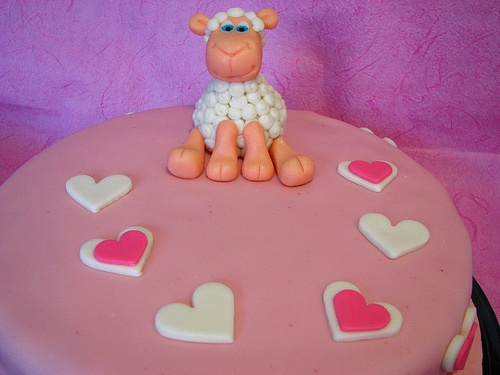Describe the objects in this image and their specific colors. I can see cake in purple, salmon, and darkgray tones and sheep in purple, salmon, lightgray, and lightpink tones in this image. 